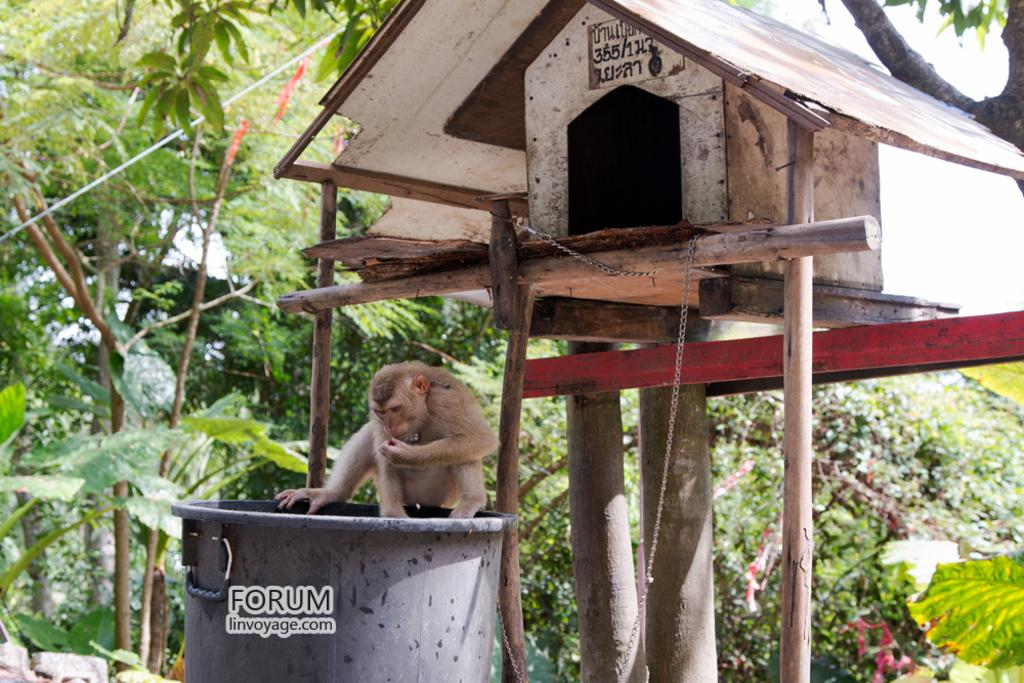What animal is present in the image? There is a monkey in the image. Where is the monkey located? The monkey is on a bin. What type of structure is visible in the image? There is a shelter in the image. How is the shelter supported? The shelter is on wooden pieces. What can be seen in the background of the image? There are trees and plants in the background of the image. What type of rhythm does the monkey exhibit while adjusting to its new environment? There is no indication in the image that the monkey is adjusting to a new environment or exhibiting any rhythm. 